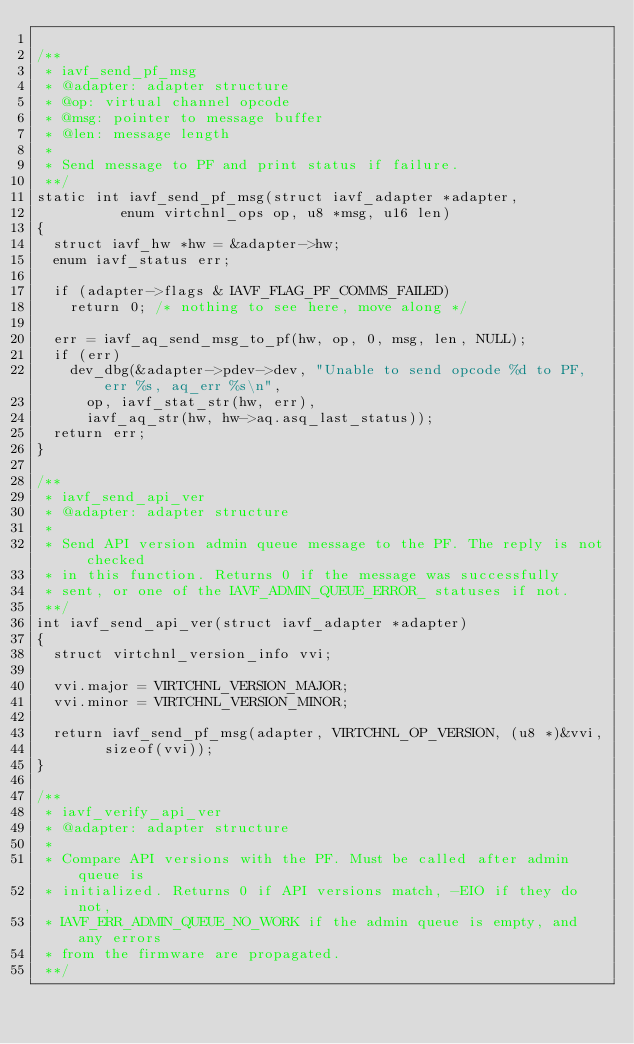<code> <loc_0><loc_0><loc_500><loc_500><_C_>
/**
 * iavf_send_pf_msg
 * @adapter: adapter structure
 * @op: virtual channel opcode
 * @msg: pointer to message buffer
 * @len: message length
 *
 * Send message to PF and print status if failure.
 **/
static int iavf_send_pf_msg(struct iavf_adapter *adapter,
			    enum virtchnl_ops op, u8 *msg, u16 len)
{
	struct iavf_hw *hw = &adapter->hw;
	enum iavf_status err;

	if (adapter->flags & IAVF_FLAG_PF_COMMS_FAILED)
		return 0; /* nothing to see here, move along */

	err = iavf_aq_send_msg_to_pf(hw, op, 0, msg, len, NULL);
	if (err)
		dev_dbg(&adapter->pdev->dev, "Unable to send opcode %d to PF, err %s, aq_err %s\n",
			op, iavf_stat_str(hw, err),
			iavf_aq_str(hw, hw->aq.asq_last_status));
	return err;
}

/**
 * iavf_send_api_ver
 * @adapter: adapter structure
 *
 * Send API version admin queue message to the PF. The reply is not checked
 * in this function. Returns 0 if the message was successfully
 * sent, or one of the IAVF_ADMIN_QUEUE_ERROR_ statuses if not.
 **/
int iavf_send_api_ver(struct iavf_adapter *adapter)
{
	struct virtchnl_version_info vvi;

	vvi.major = VIRTCHNL_VERSION_MAJOR;
	vvi.minor = VIRTCHNL_VERSION_MINOR;

	return iavf_send_pf_msg(adapter, VIRTCHNL_OP_VERSION, (u8 *)&vvi,
				sizeof(vvi));
}

/**
 * iavf_verify_api_ver
 * @adapter: adapter structure
 *
 * Compare API versions with the PF. Must be called after admin queue is
 * initialized. Returns 0 if API versions match, -EIO if they do not,
 * IAVF_ERR_ADMIN_QUEUE_NO_WORK if the admin queue is empty, and any errors
 * from the firmware are propagated.
 **/</code> 